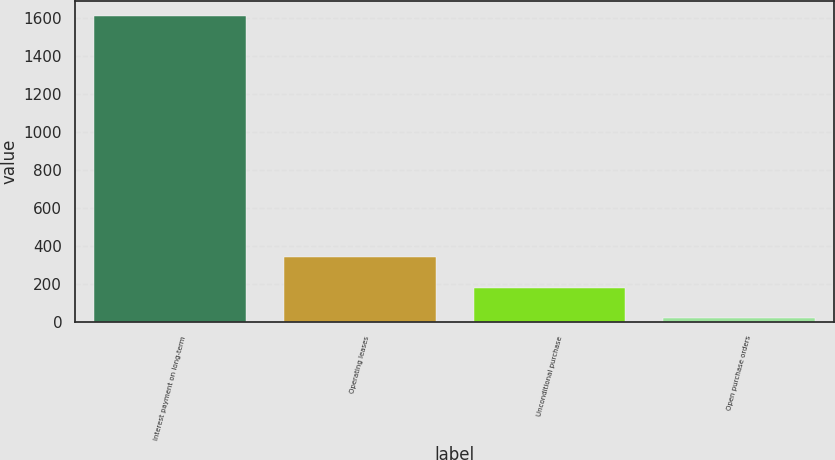<chart> <loc_0><loc_0><loc_500><loc_500><bar_chart><fcel>Interest payment on long-term<fcel>Operating leases<fcel>Unconditional purchase<fcel>Open purchase orders<nl><fcel>1608<fcel>340<fcel>181.5<fcel>23<nl></chart> 